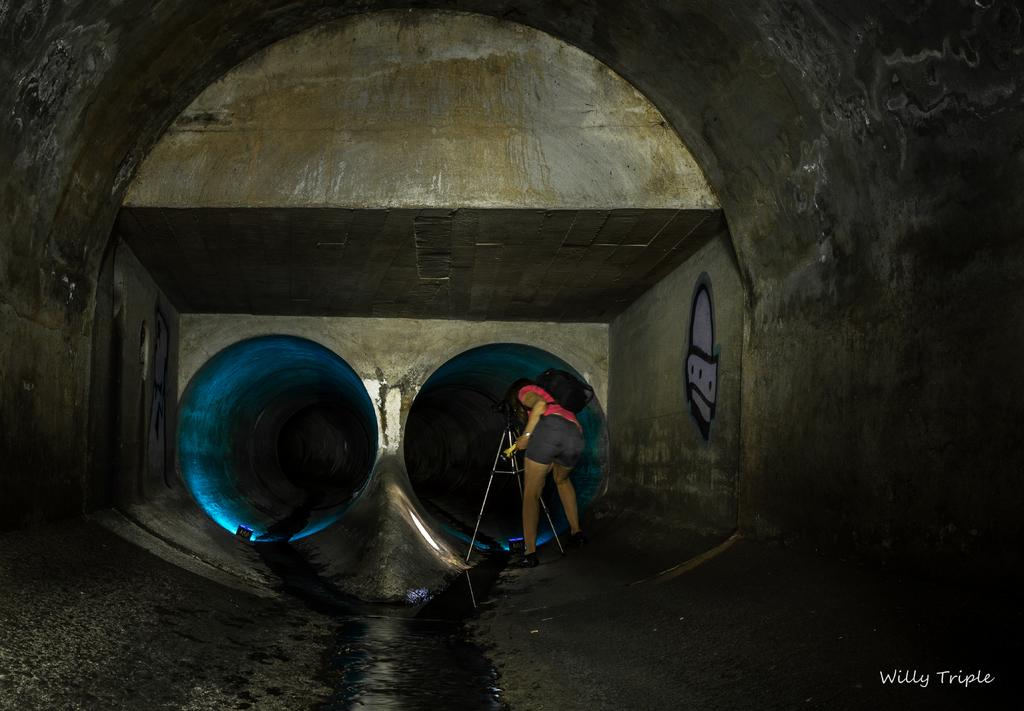What is the main subject of the image? The main subject of the image is a tunnel. Is there anyone inside the tunnel? Yes, a person is present in the tunnel. What equipment can be seen in the tunnel? There is a camera with a stand in the tunnel. How many holes are visible in the tunnel? There are two holes in the tunnel. What additional information is provided in the image? Text is visible in the bottom right corner of the image. What type of behavior is exhibited by the basket in the image? There is no basket present in the image, so it is not possible to determine any behavior. 